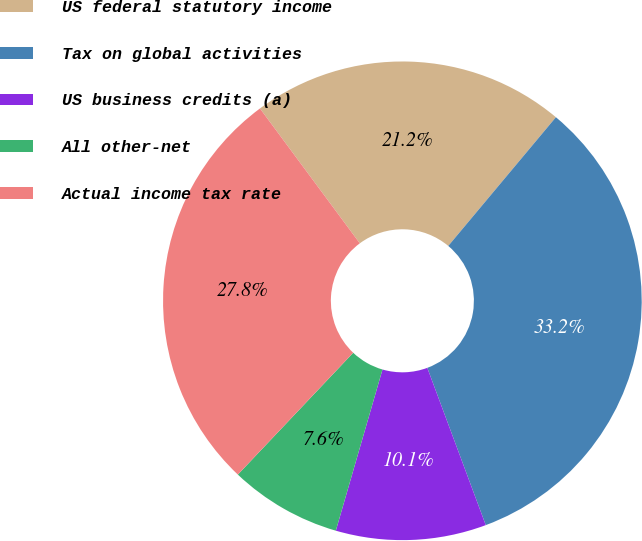Convert chart to OTSL. <chart><loc_0><loc_0><loc_500><loc_500><pie_chart><fcel>US federal statutory income<fcel>Tax on global activities<fcel>US business credits (a)<fcel>All other-net<fcel>Actual income tax rate<nl><fcel>21.23%<fcel>33.25%<fcel>10.15%<fcel>7.58%<fcel>27.79%<nl></chart> 